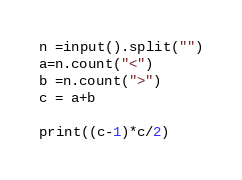<code> <loc_0><loc_0><loc_500><loc_500><_Python_>n =input().split("")
a=n.count("<")
b =n.count(">")
c = a+b

print((c-1)*c/2)
</code> 